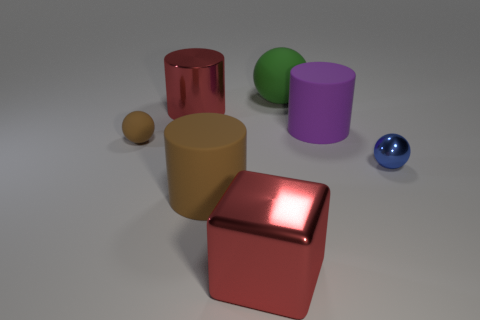What color is the block that is the same size as the green object?
Offer a terse response. Red. What number of large blue rubber cylinders are there?
Give a very brief answer. 0. Do the big ball behind the large purple matte cylinder and the small brown thing have the same material?
Provide a succinct answer. Yes. What material is the large object that is both left of the large metal block and behind the big brown rubber object?
Keep it short and to the point. Metal. There is a cylinder that is the same color as the small rubber object; what size is it?
Keep it short and to the point. Large. What material is the tiny object that is on the left side of the red thing that is in front of the blue ball?
Your answer should be very brief. Rubber. How big is the green thing behind the rubber cylinder in front of the tiny object behind the tiny blue ball?
Make the answer very short. Large. What number of small brown spheres are made of the same material as the large green thing?
Your answer should be compact. 1. The large rubber cylinder right of the red object in front of the blue metallic object is what color?
Offer a terse response. Purple. What number of objects are either big gray matte cubes or brown objects that are on the right side of the small matte sphere?
Your answer should be very brief. 1. 